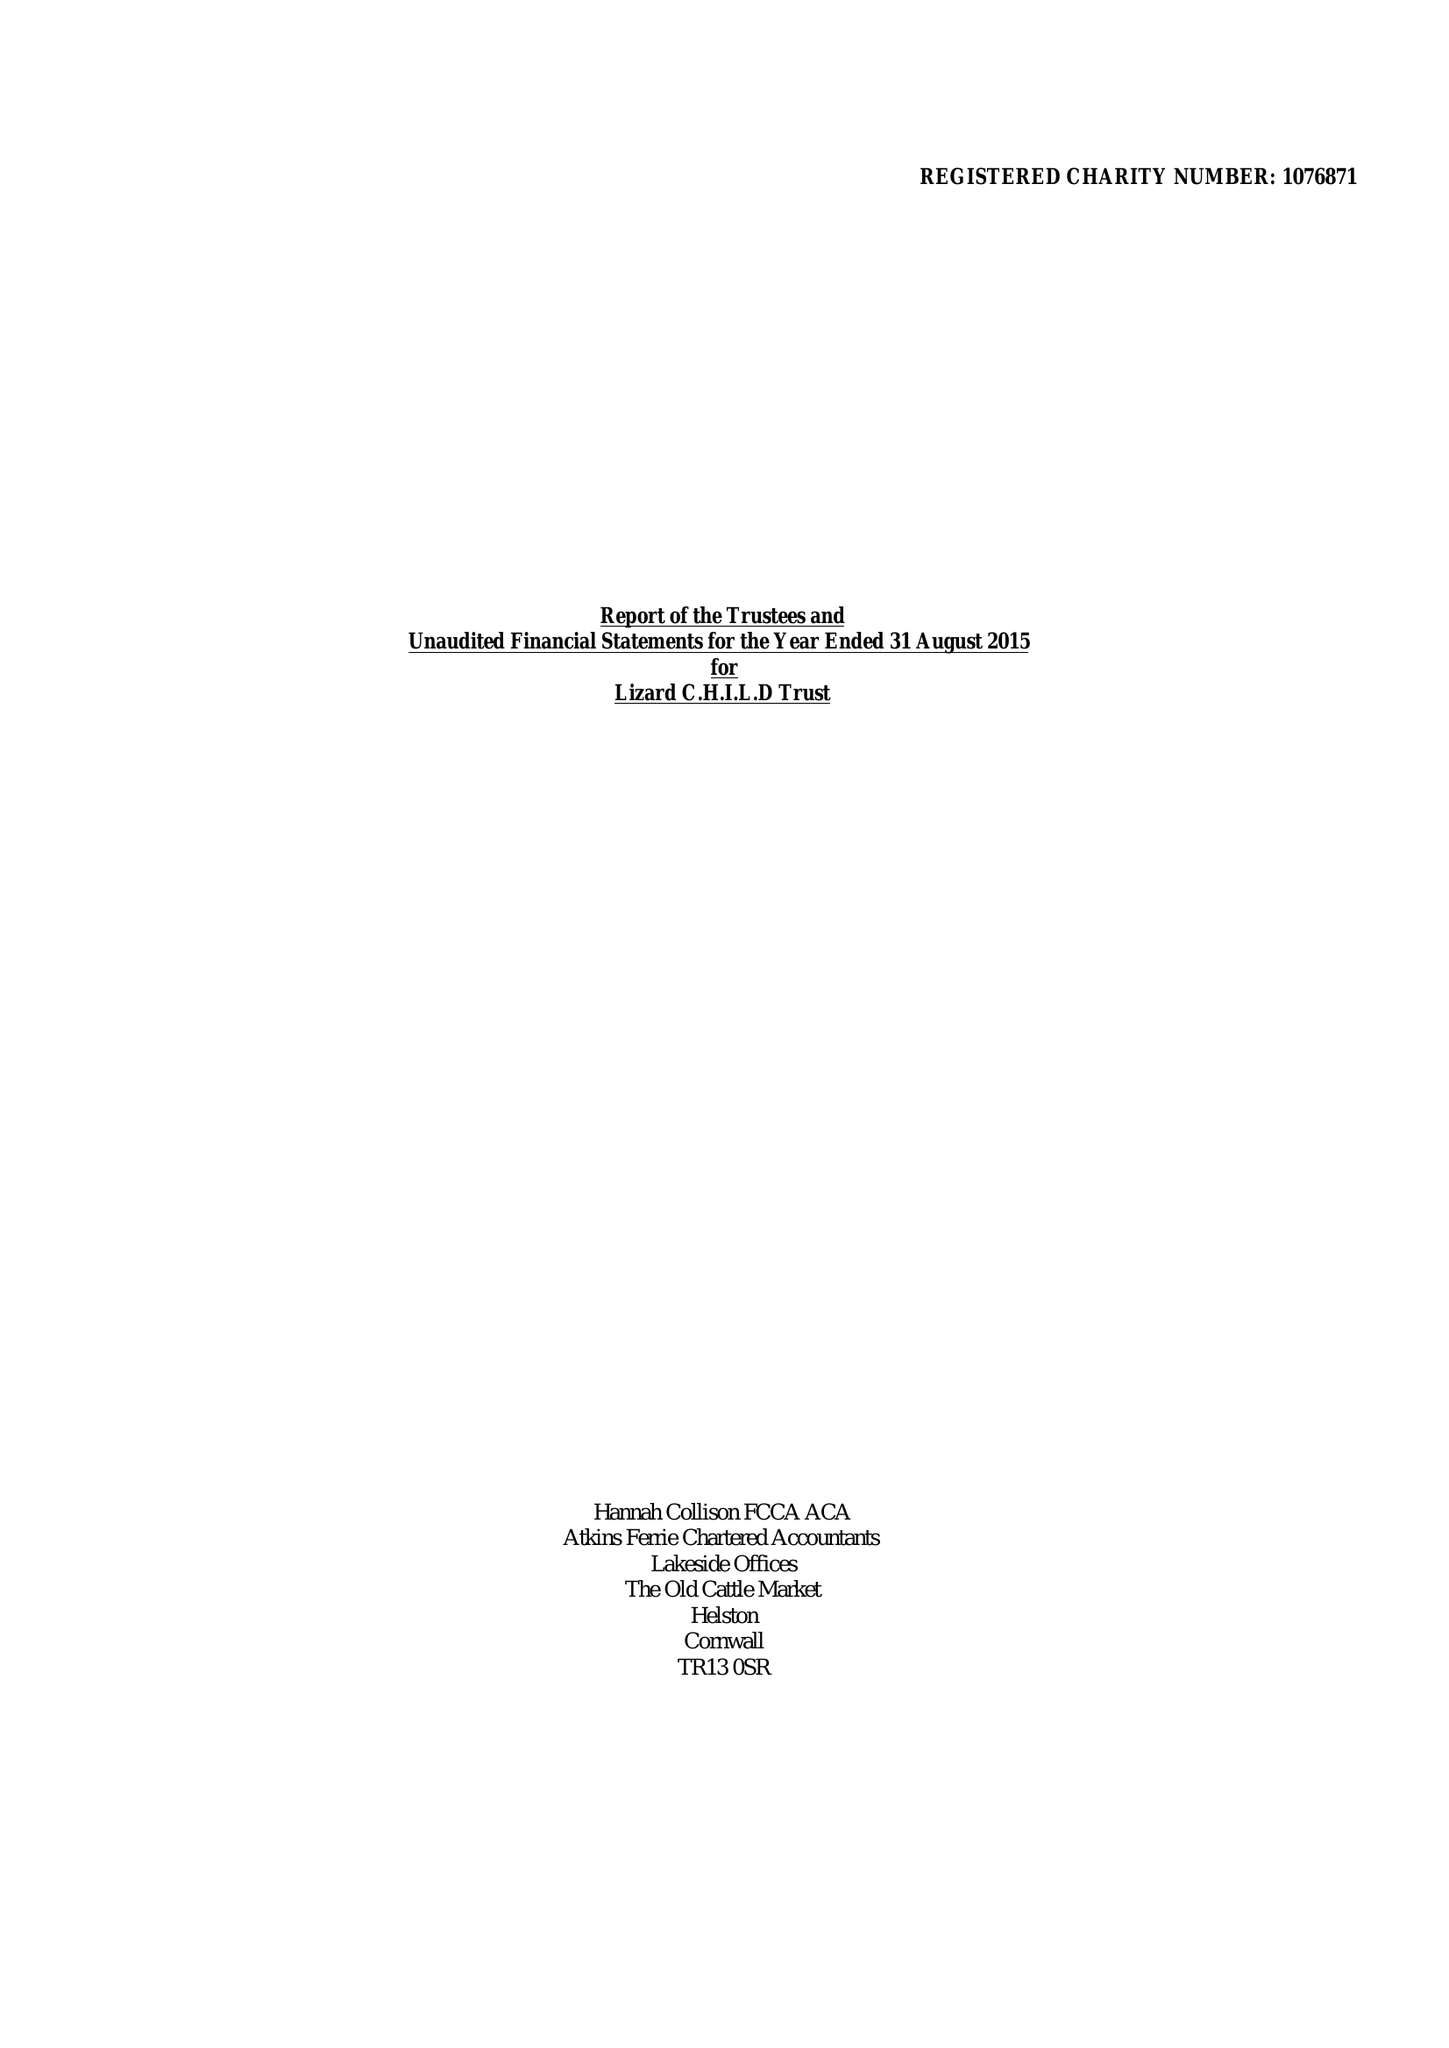What is the value for the address__postcode?
Answer the question using a single word or phrase. TR13 8AR 